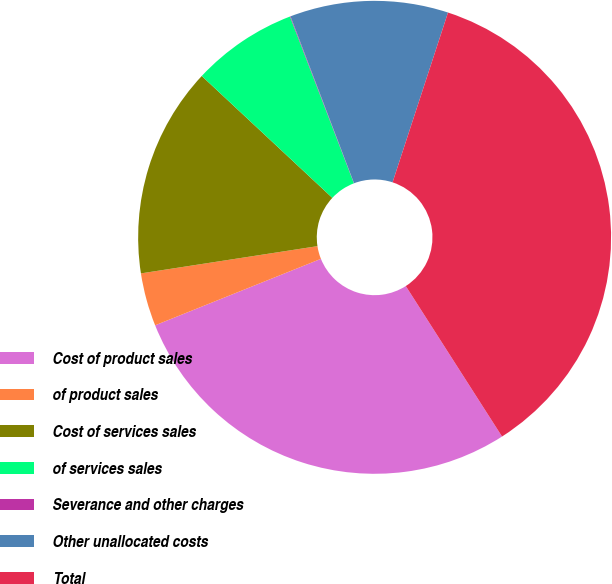Convert chart to OTSL. <chart><loc_0><loc_0><loc_500><loc_500><pie_chart><fcel>Cost of product sales<fcel>of product sales<fcel>Cost of services sales<fcel>of services sales<fcel>Severance and other charges<fcel>Other unallocated costs<fcel>Total<nl><fcel>27.99%<fcel>3.63%<fcel>14.39%<fcel>7.22%<fcel>0.04%<fcel>10.81%<fcel>35.92%<nl></chart> 